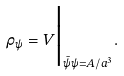<formula> <loc_0><loc_0><loc_500><loc_500>\rho _ { \psi } = V \Big | _ { \bar { \psi } \psi = A / a ^ { 3 } } .</formula> 